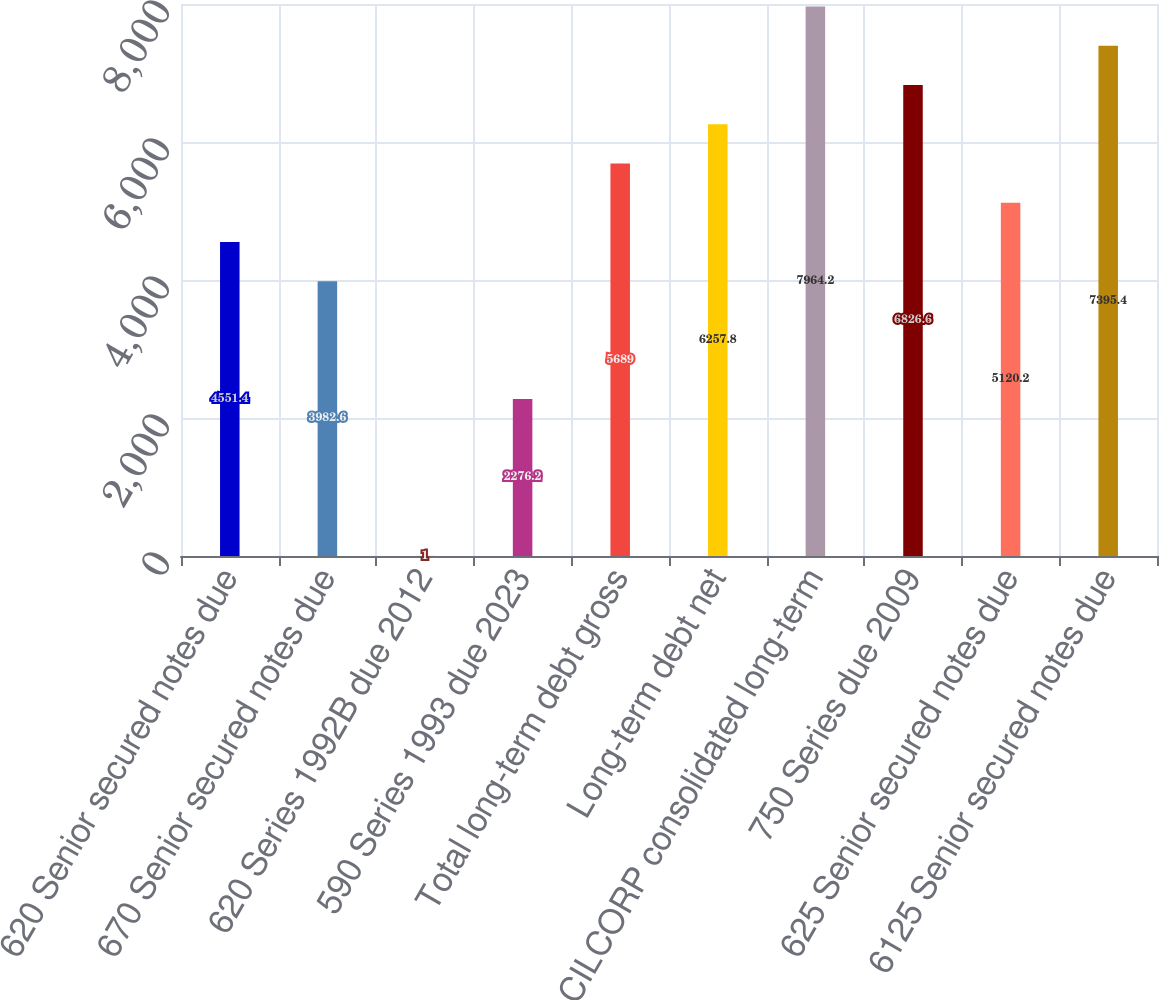Convert chart to OTSL. <chart><loc_0><loc_0><loc_500><loc_500><bar_chart><fcel>620 Senior secured notes due<fcel>670 Senior secured notes due<fcel>620 Series 1992B due 2012<fcel>590 Series 1993 due 2023<fcel>Total long-term debt gross<fcel>Long-term debt net<fcel>CILCORP consolidated long-term<fcel>750 Series due 2009<fcel>625 Senior secured notes due<fcel>6125 Senior secured notes due<nl><fcel>4551.4<fcel>3982.6<fcel>1<fcel>2276.2<fcel>5689<fcel>6257.8<fcel>7964.2<fcel>6826.6<fcel>5120.2<fcel>7395.4<nl></chart> 